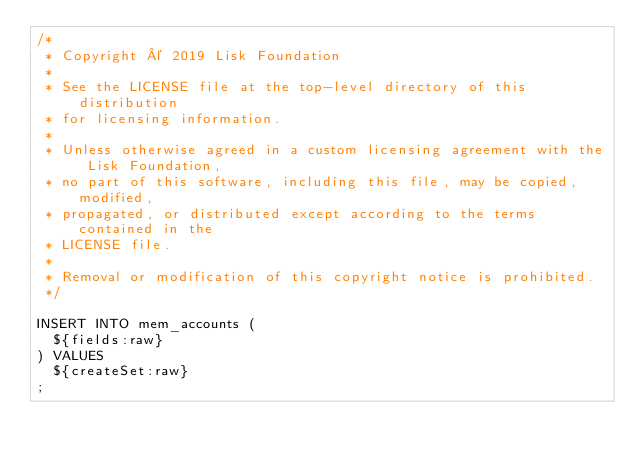<code> <loc_0><loc_0><loc_500><loc_500><_SQL_>/*
 * Copyright © 2019 Lisk Foundation
 *
 * See the LICENSE file at the top-level directory of this distribution
 * for licensing information.
 *
 * Unless otherwise agreed in a custom licensing agreement with the Lisk Foundation,
 * no part of this software, including this file, may be copied, modified,
 * propagated, or distributed except according to the terms contained in the
 * LICENSE file.
 *
 * Removal or modification of this copyright notice is prohibited.
 */

INSERT INTO mem_accounts (
	${fields:raw}
) VALUES
	${createSet:raw}
;
</code> 